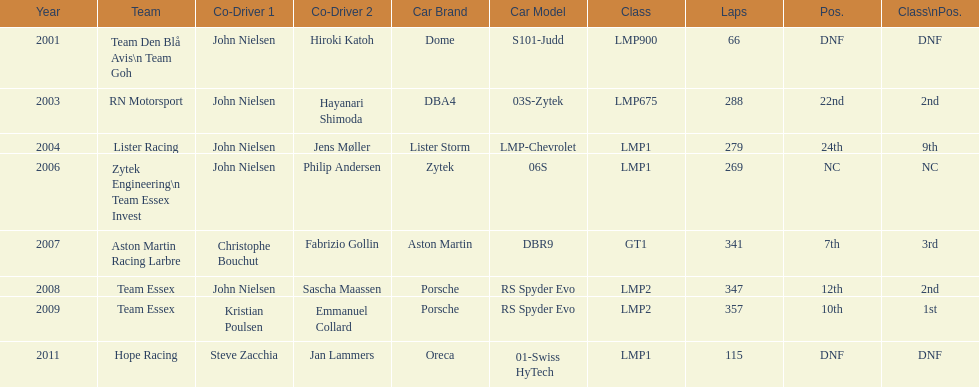How many times was the porsche rs spyder used in competition? 2. 